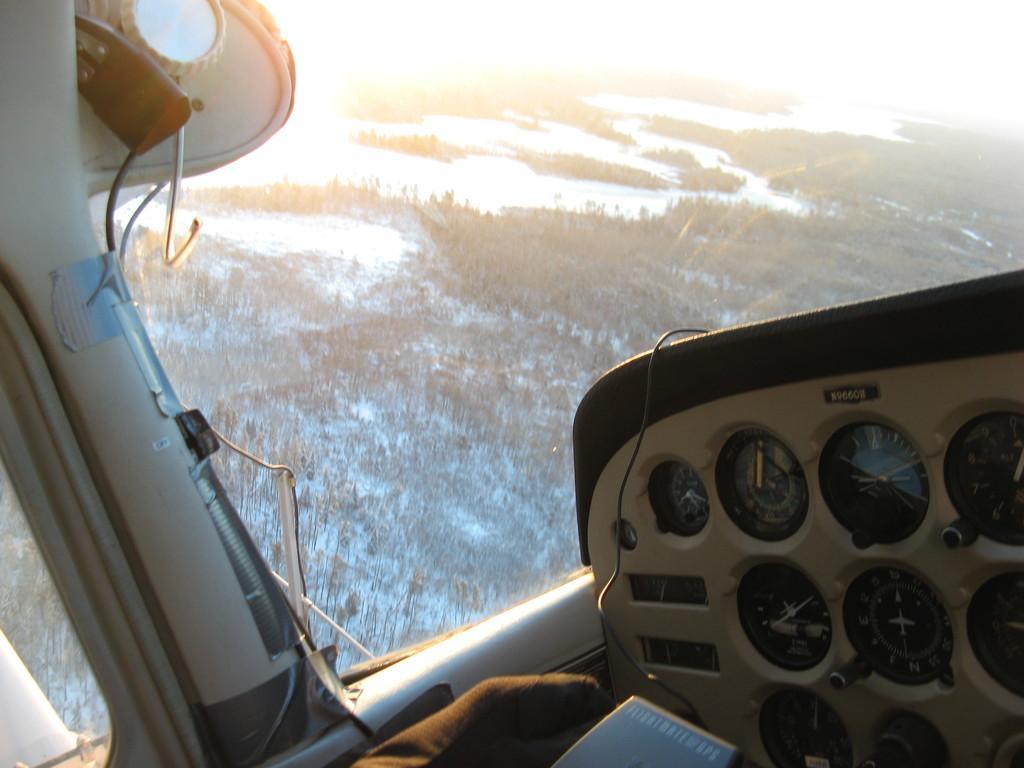Describe this image in one or two sentences. In this image we can see cockpit of a plane with speedometers. There is a glass window through which we can see trees and water. 